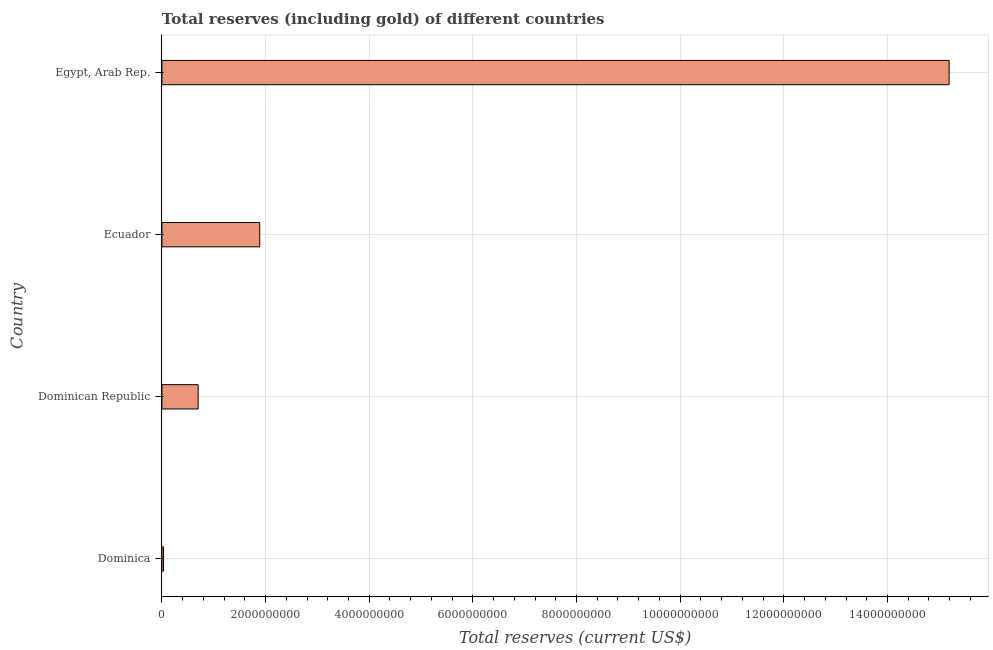What is the title of the graph?
Keep it short and to the point. Total reserves (including gold) of different countries. What is the label or title of the X-axis?
Offer a very short reply. Total reserves (current US$). What is the label or title of the Y-axis?
Ensure brevity in your answer.  Country. What is the total reserves (including gold) in Egypt, Arab Rep.?
Provide a short and direct response. 1.52e+1. Across all countries, what is the maximum total reserves (including gold)?
Your response must be concise. 1.52e+1. Across all countries, what is the minimum total reserves (including gold)?
Offer a very short reply. 3.16e+07. In which country was the total reserves (including gold) maximum?
Give a very brief answer. Egypt, Arab Rep. In which country was the total reserves (including gold) minimum?
Ensure brevity in your answer.  Dominica. What is the sum of the total reserves (including gold)?
Ensure brevity in your answer.  1.78e+1. What is the difference between the total reserves (including gold) in Dominica and Dominican Republic?
Your answer should be very brief. -6.68e+08. What is the average total reserves (including gold) per country?
Your answer should be very brief. 4.45e+09. What is the median total reserves (including gold)?
Ensure brevity in your answer.  1.29e+09. In how many countries, is the total reserves (including gold) greater than 10000000000 US$?
Your response must be concise. 1. What is the ratio of the total reserves (including gold) in Dominican Republic to that in Egypt, Arab Rep.?
Keep it short and to the point. 0.05. Is the total reserves (including gold) in Dominican Republic less than that in Egypt, Arab Rep.?
Give a very brief answer. Yes. Is the difference between the total reserves (including gold) in Ecuador and Egypt, Arab Rep. greater than the difference between any two countries?
Your answer should be very brief. No. What is the difference between the highest and the second highest total reserves (including gold)?
Give a very brief answer. 1.33e+1. What is the difference between the highest and the lowest total reserves (including gold)?
Offer a very short reply. 1.52e+1. In how many countries, is the total reserves (including gold) greater than the average total reserves (including gold) taken over all countries?
Your answer should be very brief. 1. Are all the bars in the graph horizontal?
Your response must be concise. Yes. What is the difference between two consecutive major ticks on the X-axis?
Provide a succinct answer. 2.00e+09. What is the Total reserves (current US$) in Dominica?
Offer a terse response. 3.16e+07. What is the Total reserves (current US$) of Dominican Republic?
Your answer should be very brief. 6.99e+08. What is the Total reserves (current US$) in Ecuador?
Ensure brevity in your answer.  1.89e+09. What is the Total reserves (current US$) in Egypt, Arab Rep.?
Ensure brevity in your answer.  1.52e+1. What is the difference between the Total reserves (current US$) in Dominica and Dominican Republic?
Offer a very short reply. -6.68e+08. What is the difference between the Total reserves (current US$) in Dominica and Ecuador?
Provide a short and direct response. -1.86e+09. What is the difference between the Total reserves (current US$) in Dominica and Egypt, Arab Rep.?
Keep it short and to the point. -1.52e+1. What is the difference between the Total reserves (current US$) in Dominican Republic and Ecuador?
Make the answer very short. -1.19e+09. What is the difference between the Total reserves (current US$) in Dominican Republic and Egypt, Arab Rep.?
Offer a terse response. -1.45e+1. What is the difference between the Total reserves (current US$) in Ecuador and Egypt, Arab Rep.?
Keep it short and to the point. -1.33e+1. What is the ratio of the Total reserves (current US$) in Dominica to that in Dominican Republic?
Offer a terse response. 0.04. What is the ratio of the Total reserves (current US$) in Dominica to that in Ecuador?
Make the answer very short. 0.02. What is the ratio of the Total reserves (current US$) in Dominica to that in Egypt, Arab Rep.?
Ensure brevity in your answer.  0. What is the ratio of the Total reserves (current US$) in Dominican Republic to that in Ecuador?
Offer a very short reply. 0.37. What is the ratio of the Total reserves (current US$) in Dominican Republic to that in Egypt, Arab Rep.?
Make the answer very short. 0.05. What is the ratio of the Total reserves (current US$) in Ecuador to that in Egypt, Arab Rep.?
Ensure brevity in your answer.  0.12. 